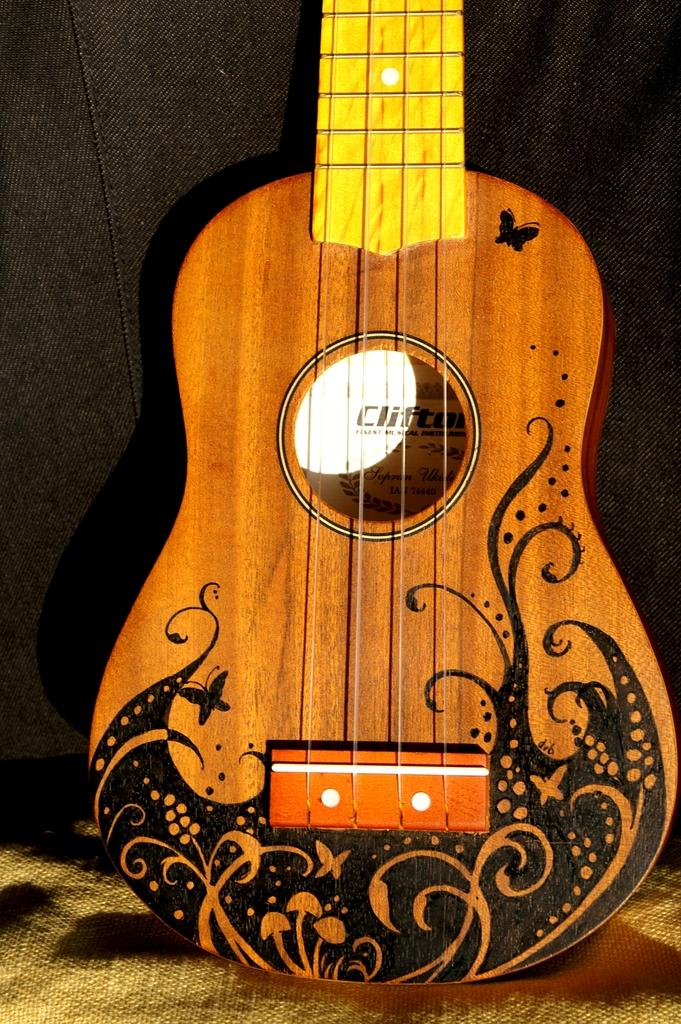What type of musical instrument is present in the image? There is a truncated guitar in the image. What type of print can be seen on the celery in the image? There is no celery present in the image, and therefore no print can be observed. What song is being played on the guitar in the image? The image only shows a truncated guitar, and there is no indication of a song being played. 